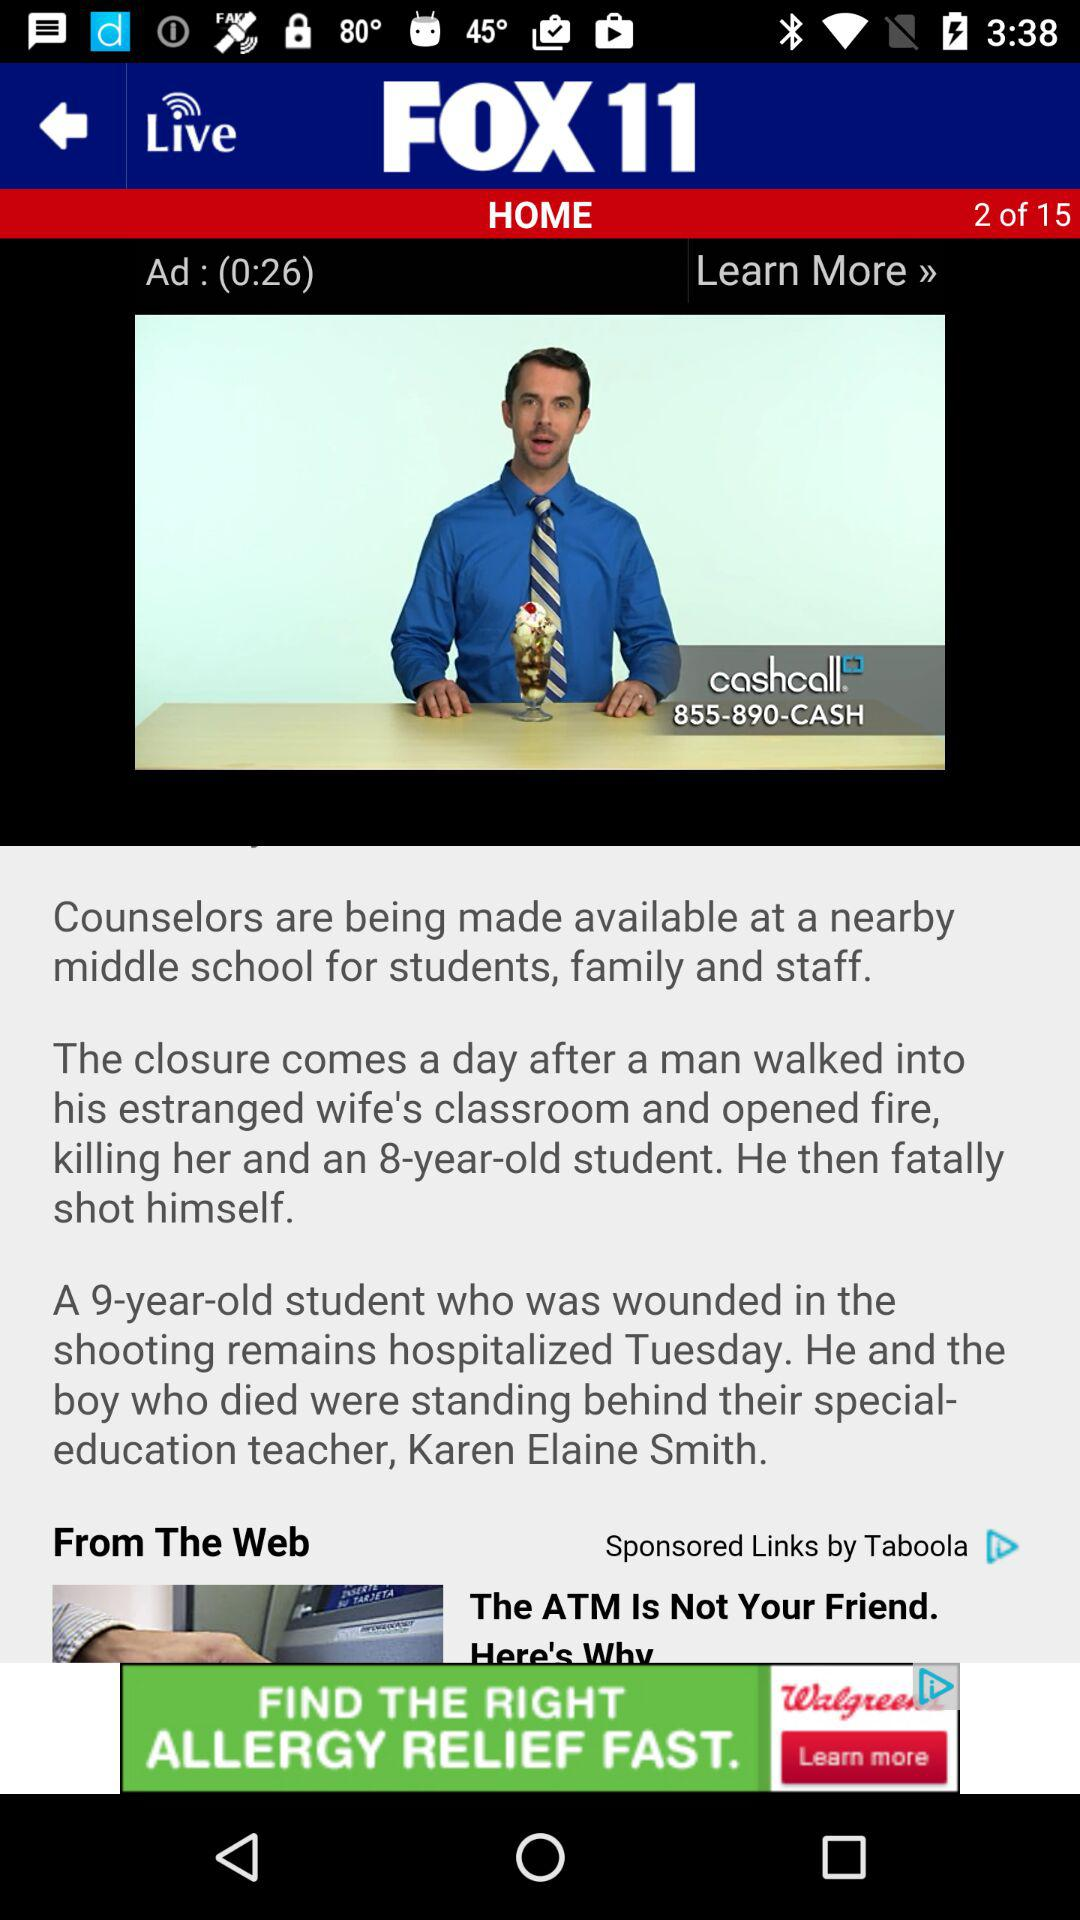Which is the current page number? The current page number is 2. 